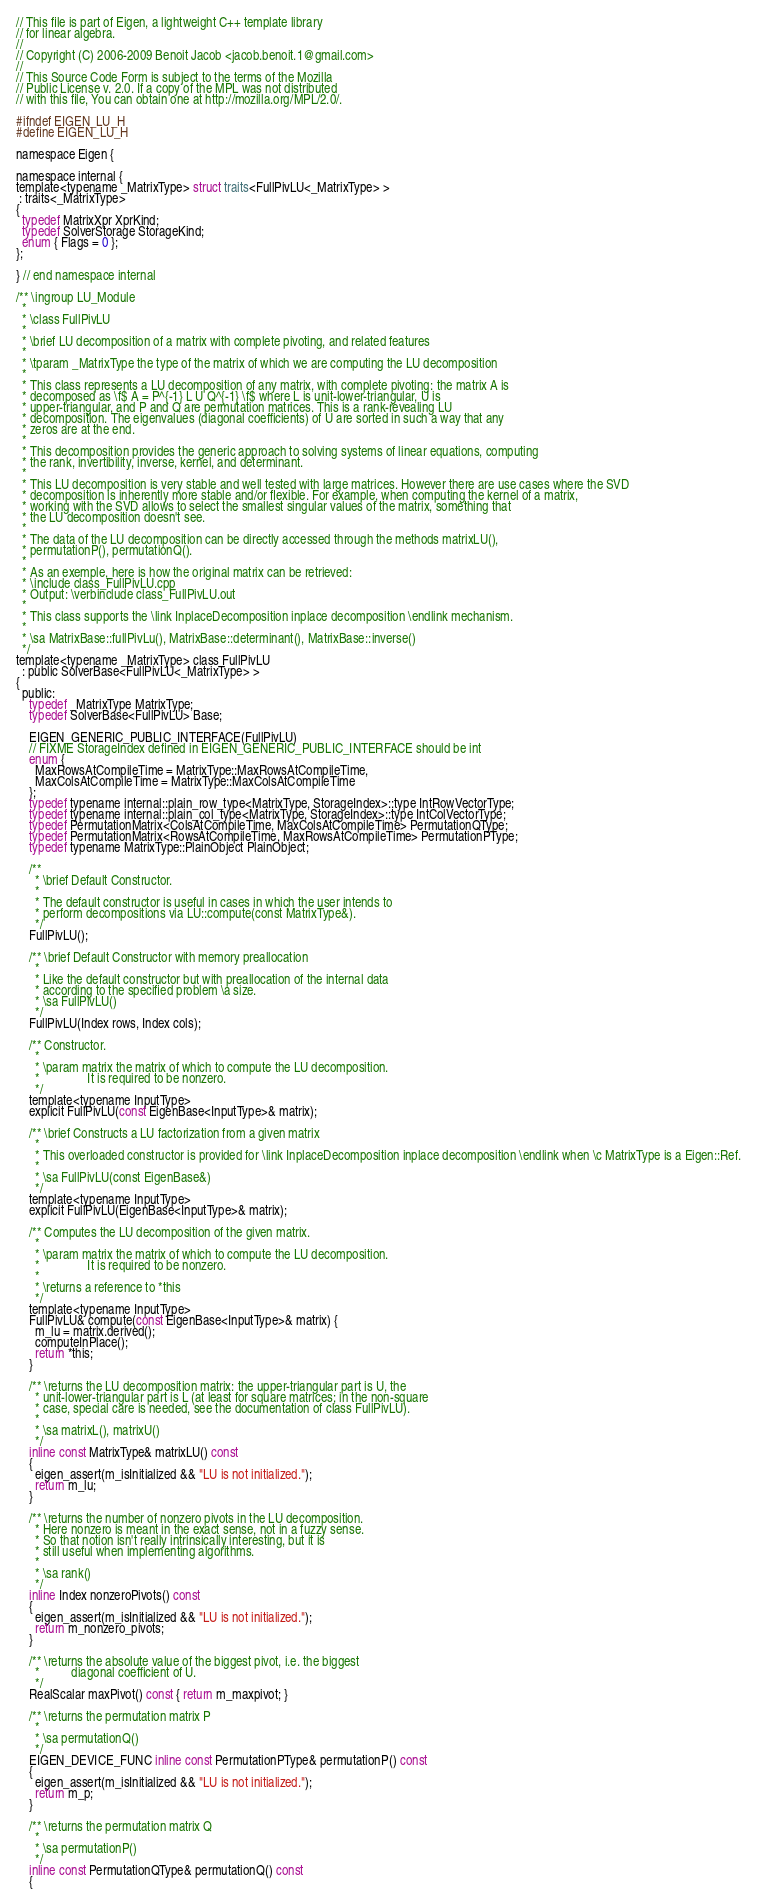<code> <loc_0><loc_0><loc_500><loc_500><_C_>// This file is part of Eigen, a lightweight C++ template library
// for linear algebra.
//
// Copyright (C) 2006-2009 Benoit Jacob <jacob.benoit.1@gmail.com>
//
// This Source Code Form is subject to the terms of the Mozilla
// Public License v. 2.0. If a copy of the MPL was not distributed
// with this file, You can obtain one at http://mozilla.org/MPL/2.0/.

#ifndef EIGEN_LU_H
#define EIGEN_LU_H

namespace Eigen {

namespace internal {
template<typename _MatrixType> struct traits<FullPivLU<_MatrixType> >
 : traits<_MatrixType>
{
  typedef MatrixXpr XprKind;
  typedef SolverStorage StorageKind;
  enum { Flags = 0 };
};

} // end namespace internal

/** \ingroup LU_Module
  *
  * \class FullPivLU
  *
  * \brief LU decomposition of a matrix with complete pivoting, and related features
  *
  * \tparam _MatrixType the type of the matrix of which we are computing the LU decomposition
  *
  * This class represents a LU decomposition of any matrix, with complete pivoting: the matrix A is
  * decomposed as \f$ A = P^{-1} L U Q^{-1} \f$ where L is unit-lower-triangular, U is
  * upper-triangular, and P and Q are permutation matrices. This is a rank-revealing LU
  * decomposition. The eigenvalues (diagonal coefficients) of U are sorted in such a way that any
  * zeros are at the end.
  *
  * This decomposition provides the generic approach to solving systems of linear equations, computing
  * the rank, invertibility, inverse, kernel, and determinant.
  *
  * This LU decomposition is very stable and well tested with large matrices. However there are use cases where the SVD
  * decomposition is inherently more stable and/or flexible. For example, when computing the kernel of a matrix,
  * working with the SVD allows to select the smallest singular values of the matrix, something that
  * the LU decomposition doesn't see.
  *
  * The data of the LU decomposition can be directly accessed through the methods matrixLU(),
  * permutationP(), permutationQ().
  *
  * As an exemple, here is how the original matrix can be retrieved:
  * \include class_FullPivLU.cpp
  * Output: \verbinclude class_FullPivLU.out
  *
  * This class supports the \link InplaceDecomposition inplace decomposition \endlink mechanism.
  * 
  * \sa MatrixBase::fullPivLu(), MatrixBase::determinant(), MatrixBase::inverse()
  */
template<typename _MatrixType> class FullPivLU
  : public SolverBase<FullPivLU<_MatrixType> >
{
  public:
    typedef _MatrixType MatrixType;
    typedef SolverBase<FullPivLU> Base;

    EIGEN_GENERIC_PUBLIC_INTERFACE(FullPivLU)
    // FIXME StorageIndex defined in EIGEN_GENERIC_PUBLIC_INTERFACE should be int
    enum {
      MaxRowsAtCompileTime = MatrixType::MaxRowsAtCompileTime,
      MaxColsAtCompileTime = MatrixType::MaxColsAtCompileTime
    };
    typedef typename internal::plain_row_type<MatrixType, StorageIndex>::type IntRowVectorType;
    typedef typename internal::plain_col_type<MatrixType, StorageIndex>::type IntColVectorType;
    typedef PermutationMatrix<ColsAtCompileTime, MaxColsAtCompileTime> PermutationQType;
    typedef PermutationMatrix<RowsAtCompileTime, MaxRowsAtCompileTime> PermutationPType;
    typedef typename MatrixType::PlainObject PlainObject;

    /**
      * \brief Default Constructor.
      *
      * The default constructor is useful in cases in which the user intends to
      * perform decompositions via LU::compute(const MatrixType&).
      */
    FullPivLU();

    /** \brief Default Constructor with memory preallocation
      *
      * Like the default constructor but with preallocation of the internal data
      * according to the specified problem \a size.
      * \sa FullPivLU()
      */
    FullPivLU(Index rows, Index cols);

    /** Constructor.
      *
      * \param matrix the matrix of which to compute the LU decomposition.
      *               It is required to be nonzero.
      */
    template<typename InputType>
    explicit FullPivLU(const EigenBase<InputType>& matrix);

    /** \brief Constructs a LU factorization from a given matrix
      *
      * This overloaded constructor is provided for \link InplaceDecomposition inplace decomposition \endlink when \c MatrixType is a Eigen::Ref.
      *
      * \sa FullPivLU(const EigenBase&)
      */
    template<typename InputType>
    explicit FullPivLU(EigenBase<InputType>& matrix);

    /** Computes the LU decomposition of the given matrix.
      *
      * \param matrix the matrix of which to compute the LU decomposition.
      *               It is required to be nonzero.
      *
      * \returns a reference to *this
      */
    template<typename InputType>
    FullPivLU& compute(const EigenBase<InputType>& matrix) {
      m_lu = matrix.derived();
      computeInPlace();
      return *this;
    }

    /** \returns the LU decomposition matrix: the upper-triangular part is U, the
      * unit-lower-triangular part is L (at least for square matrices; in the non-square
      * case, special care is needed, see the documentation of class FullPivLU).
      *
      * \sa matrixL(), matrixU()
      */
    inline const MatrixType& matrixLU() const
    {
      eigen_assert(m_isInitialized && "LU is not initialized.");
      return m_lu;
    }

    /** \returns the number of nonzero pivots in the LU decomposition.
      * Here nonzero is meant in the exact sense, not in a fuzzy sense.
      * So that notion isn't really intrinsically interesting, but it is
      * still useful when implementing algorithms.
      *
      * \sa rank()
      */
    inline Index nonzeroPivots() const
    {
      eigen_assert(m_isInitialized && "LU is not initialized.");
      return m_nonzero_pivots;
    }

    /** \returns the absolute value of the biggest pivot, i.e. the biggest
      *          diagonal coefficient of U.
      */
    RealScalar maxPivot() const { return m_maxpivot; }

    /** \returns the permutation matrix P
      *
      * \sa permutationQ()
      */
    EIGEN_DEVICE_FUNC inline const PermutationPType& permutationP() const
    {
      eigen_assert(m_isInitialized && "LU is not initialized.");
      return m_p;
    }

    /** \returns the permutation matrix Q
      *
      * \sa permutationP()
      */
    inline const PermutationQType& permutationQ() const
    {</code> 